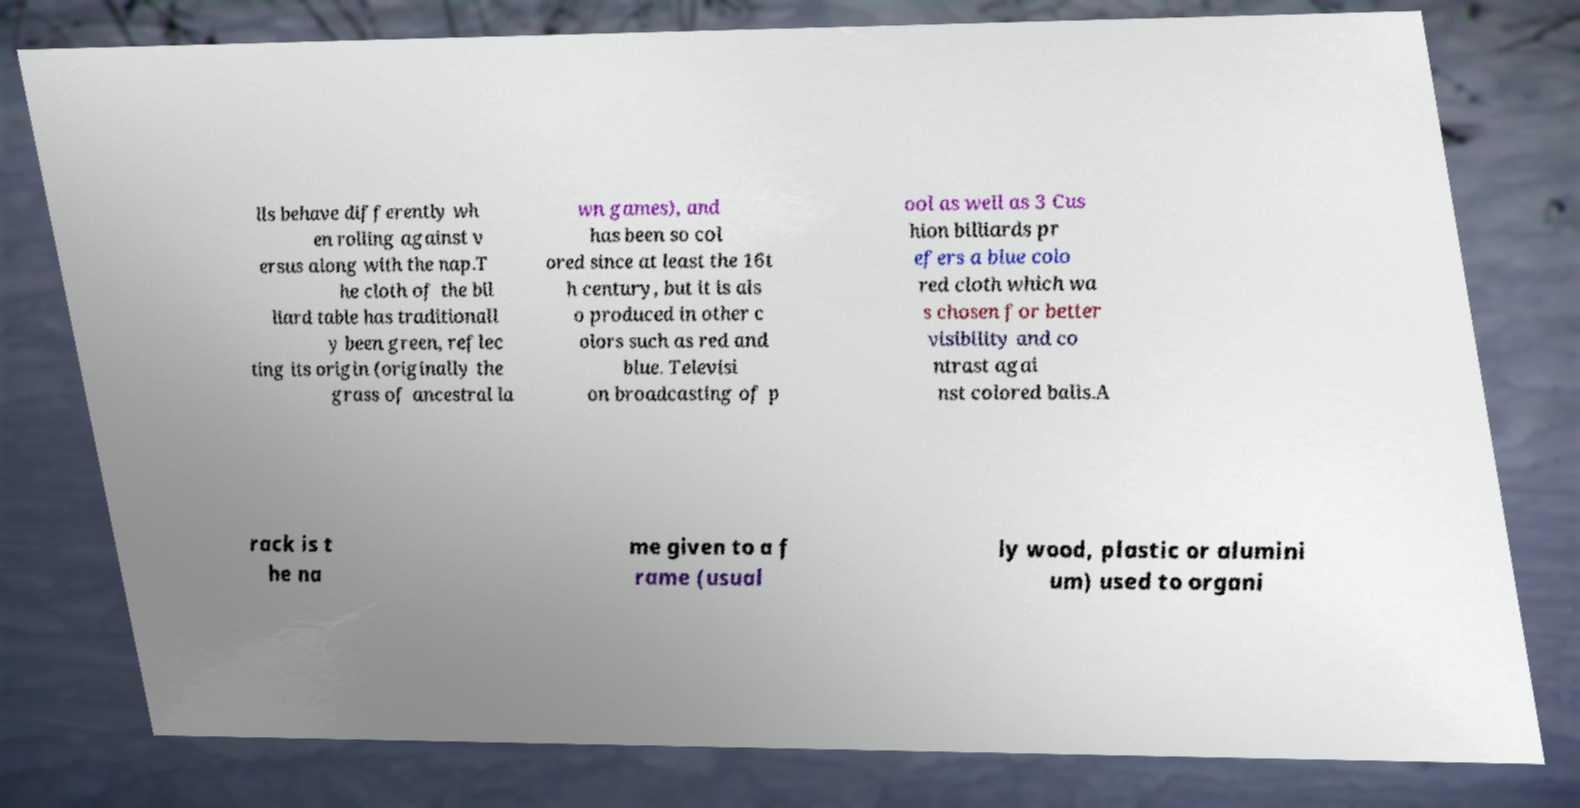I need the written content from this picture converted into text. Can you do that? lls behave differently wh en rolling against v ersus along with the nap.T he cloth of the bil liard table has traditionall y been green, reflec ting its origin (originally the grass of ancestral la wn games), and has been so col ored since at least the 16t h century, but it is als o produced in other c olors such as red and blue. Televisi on broadcasting of p ool as well as 3 Cus hion billiards pr efers a blue colo red cloth which wa s chosen for better visibility and co ntrast agai nst colored balls.A rack is t he na me given to a f rame (usual ly wood, plastic or alumini um) used to organi 